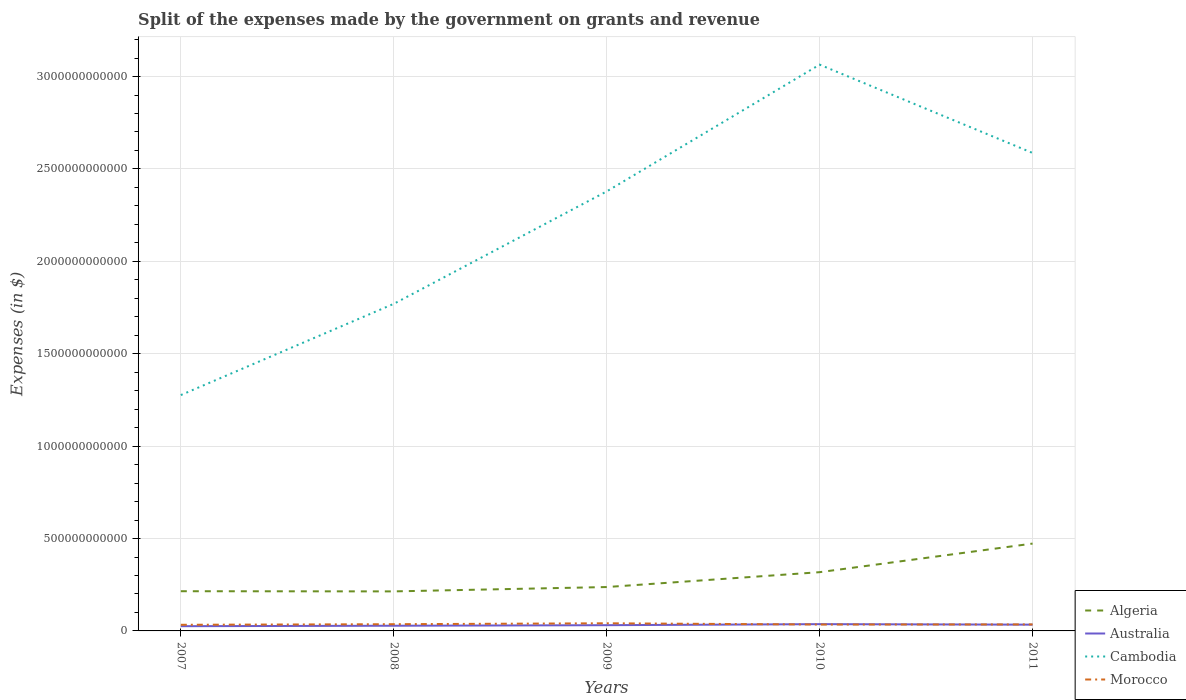How many different coloured lines are there?
Ensure brevity in your answer.  4. Across all years, what is the maximum expenses made by the government on grants and revenue in Morocco?
Your answer should be very brief. 3.32e+1. What is the total expenses made by the government on grants and revenue in Australia in the graph?
Keep it short and to the point. -5.63e+09. What is the difference between the highest and the second highest expenses made by the government on grants and revenue in Australia?
Keep it short and to the point. 1.11e+1. What is the difference between the highest and the lowest expenses made by the government on grants and revenue in Morocco?
Offer a very short reply. 2. Is the expenses made by the government on grants and revenue in Australia strictly greater than the expenses made by the government on grants and revenue in Algeria over the years?
Make the answer very short. Yes. How many lines are there?
Ensure brevity in your answer.  4. How many years are there in the graph?
Give a very brief answer. 5. What is the difference between two consecutive major ticks on the Y-axis?
Your answer should be very brief. 5.00e+11. Are the values on the major ticks of Y-axis written in scientific E-notation?
Your answer should be very brief. No. Does the graph contain grids?
Your answer should be very brief. Yes. Where does the legend appear in the graph?
Your answer should be compact. Bottom right. How many legend labels are there?
Offer a very short reply. 4. How are the legend labels stacked?
Provide a succinct answer. Vertical. What is the title of the graph?
Keep it short and to the point. Split of the expenses made by the government on grants and revenue. Does "Djibouti" appear as one of the legend labels in the graph?
Your answer should be compact. No. What is the label or title of the Y-axis?
Your answer should be compact. Expenses (in $). What is the Expenses (in $) of Algeria in 2007?
Your response must be concise. 2.15e+11. What is the Expenses (in $) of Australia in 2007?
Make the answer very short. 2.56e+1. What is the Expenses (in $) of Cambodia in 2007?
Offer a terse response. 1.28e+12. What is the Expenses (in $) of Morocco in 2007?
Offer a terse response. 3.32e+1. What is the Expenses (in $) in Algeria in 2008?
Offer a very short reply. 2.14e+11. What is the Expenses (in $) in Australia in 2008?
Make the answer very short. 2.81e+1. What is the Expenses (in $) of Cambodia in 2008?
Make the answer very short. 1.77e+12. What is the Expenses (in $) of Morocco in 2008?
Give a very brief answer. 3.64e+1. What is the Expenses (in $) in Algeria in 2009?
Provide a succinct answer. 2.37e+11. What is the Expenses (in $) of Australia in 2009?
Make the answer very short. 3.10e+1. What is the Expenses (in $) in Cambodia in 2009?
Give a very brief answer. 2.38e+12. What is the Expenses (in $) in Morocco in 2009?
Your response must be concise. 4.13e+1. What is the Expenses (in $) of Algeria in 2010?
Provide a short and direct response. 3.18e+11. What is the Expenses (in $) in Australia in 2010?
Make the answer very short. 3.67e+1. What is the Expenses (in $) of Cambodia in 2010?
Offer a very short reply. 3.06e+12. What is the Expenses (in $) of Morocco in 2010?
Your answer should be very brief. 3.46e+1. What is the Expenses (in $) of Algeria in 2011?
Your answer should be very brief. 4.73e+11. What is the Expenses (in $) of Australia in 2011?
Ensure brevity in your answer.  3.39e+1. What is the Expenses (in $) of Cambodia in 2011?
Keep it short and to the point. 2.59e+12. What is the Expenses (in $) in Morocco in 2011?
Provide a short and direct response. 3.52e+1. Across all years, what is the maximum Expenses (in $) of Algeria?
Keep it short and to the point. 4.73e+11. Across all years, what is the maximum Expenses (in $) of Australia?
Ensure brevity in your answer.  3.67e+1. Across all years, what is the maximum Expenses (in $) in Cambodia?
Your response must be concise. 3.06e+12. Across all years, what is the maximum Expenses (in $) of Morocco?
Your response must be concise. 4.13e+1. Across all years, what is the minimum Expenses (in $) in Algeria?
Keep it short and to the point. 2.14e+11. Across all years, what is the minimum Expenses (in $) of Australia?
Your answer should be compact. 2.56e+1. Across all years, what is the minimum Expenses (in $) in Cambodia?
Your answer should be compact. 1.28e+12. Across all years, what is the minimum Expenses (in $) of Morocco?
Offer a terse response. 3.32e+1. What is the total Expenses (in $) in Algeria in the graph?
Provide a short and direct response. 1.46e+12. What is the total Expenses (in $) in Australia in the graph?
Provide a short and direct response. 1.55e+11. What is the total Expenses (in $) in Cambodia in the graph?
Offer a terse response. 1.11e+13. What is the total Expenses (in $) of Morocco in the graph?
Offer a very short reply. 1.81e+11. What is the difference between the Expenses (in $) in Algeria in 2007 and that in 2008?
Offer a very short reply. 9.60e+08. What is the difference between the Expenses (in $) of Australia in 2007 and that in 2008?
Give a very brief answer. -2.50e+09. What is the difference between the Expenses (in $) of Cambodia in 2007 and that in 2008?
Your answer should be compact. -4.94e+11. What is the difference between the Expenses (in $) in Morocco in 2007 and that in 2008?
Provide a succinct answer. -3.19e+09. What is the difference between the Expenses (in $) in Algeria in 2007 and that in 2009?
Your response must be concise. -2.26e+1. What is the difference between the Expenses (in $) of Australia in 2007 and that in 2009?
Offer a terse response. -5.43e+09. What is the difference between the Expenses (in $) in Cambodia in 2007 and that in 2009?
Offer a terse response. -1.10e+12. What is the difference between the Expenses (in $) in Morocco in 2007 and that in 2009?
Offer a terse response. -8.13e+09. What is the difference between the Expenses (in $) in Algeria in 2007 and that in 2010?
Offer a terse response. -1.03e+11. What is the difference between the Expenses (in $) of Australia in 2007 and that in 2010?
Provide a short and direct response. -1.11e+1. What is the difference between the Expenses (in $) of Cambodia in 2007 and that in 2010?
Provide a short and direct response. -1.79e+12. What is the difference between the Expenses (in $) of Morocco in 2007 and that in 2010?
Offer a very short reply. -1.40e+09. What is the difference between the Expenses (in $) of Algeria in 2007 and that in 2011?
Provide a short and direct response. -2.58e+11. What is the difference between the Expenses (in $) in Australia in 2007 and that in 2011?
Provide a short and direct response. -8.32e+09. What is the difference between the Expenses (in $) in Cambodia in 2007 and that in 2011?
Offer a terse response. -1.31e+12. What is the difference between the Expenses (in $) of Morocco in 2007 and that in 2011?
Your answer should be very brief. -2.01e+09. What is the difference between the Expenses (in $) in Algeria in 2008 and that in 2009?
Your response must be concise. -2.36e+1. What is the difference between the Expenses (in $) of Australia in 2008 and that in 2009?
Your answer should be compact. -2.93e+09. What is the difference between the Expenses (in $) in Cambodia in 2008 and that in 2009?
Keep it short and to the point. -6.08e+11. What is the difference between the Expenses (in $) in Morocco in 2008 and that in 2009?
Keep it short and to the point. -4.95e+09. What is the difference between the Expenses (in $) in Algeria in 2008 and that in 2010?
Make the answer very short. -1.04e+11. What is the difference between the Expenses (in $) in Australia in 2008 and that in 2010?
Your answer should be compact. -8.56e+09. What is the difference between the Expenses (in $) of Cambodia in 2008 and that in 2010?
Provide a short and direct response. -1.29e+12. What is the difference between the Expenses (in $) in Morocco in 2008 and that in 2010?
Provide a short and direct response. 1.79e+09. What is the difference between the Expenses (in $) in Algeria in 2008 and that in 2011?
Offer a very short reply. -2.59e+11. What is the difference between the Expenses (in $) in Australia in 2008 and that in 2011?
Your answer should be very brief. -5.81e+09. What is the difference between the Expenses (in $) in Cambodia in 2008 and that in 2011?
Your answer should be compact. -8.17e+11. What is the difference between the Expenses (in $) in Morocco in 2008 and that in 2011?
Make the answer very short. 1.17e+09. What is the difference between the Expenses (in $) in Algeria in 2009 and that in 2010?
Give a very brief answer. -8.04e+1. What is the difference between the Expenses (in $) of Australia in 2009 and that in 2010?
Make the answer very short. -5.63e+09. What is the difference between the Expenses (in $) in Cambodia in 2009 and that in 2010?
Make the answer very short. -6.86e+11. What is the difference between the Expenses (in $) in Morocco in 2009 and that in 2010?
Keep it short and to the point. 6.74e+09. What is the difference between the Expenses (in $) of Algeria in 2009 and that in 2011?
Keep it short and to the point. -2.35e+11. What is the difference between the Expenses (in $) of Australia in 2009 and that in 2011?
Your response must be concise. -2.88e+09. What is the difference between the Expenses (in $) in Cambodia in 2009 and that in 2011?
Ensure brevity in your answer.  -2.08e+11. What is the difference between the Expenses (in $) of Morocco in 2009 and that in 2011?
Ensure brevity in your answer.  6.12e+09. What is the difference between the Expenses (in $) in Algeria in 2010 and that in 2011?
Ensure brevity in your answer.  -1.55e+11. What is the difference between the Expenses (in $) of Australia in 2010 and that in 2011?
Your answer should be compact. 2.75e+09. What is the difference between the Expenses (in $) of Cambodia in 2010 and that in 2011?
Your answer should be very brief. 4.78e+11. What is the difference between the Expenses (in $) of Morocco in 2010 and that in 2011?
Ensure brevity in your answer.  -6.13e+08. What is the difference between the Expenses (in $) in Algeria in 2007 and the Expenses (in $) in Australia in 2008?
Offer a very short reply. 1.87e+11. What is the difference between the Expenses (in $) of Algeria in 2007 and the Expenses (in $) of Cambodia in 2008?
Provide a succinct answer. -1.56e+12. What is the difference between the Expenses (in $) in Algeria in 2007 and the Expenses (in $) in Morocco in 2008?
Offer a very short reply. 1.78e+11. What is the difference between the Expenses (in $) in Australia in 2007 and the Expenses (in $) in Cambodia in 2008?
Keep it short and to the point. -1.74e+12. What is the difference between the Expenses (in $) in Australia in 2007 and the Expenses (in $) in Morocco in 2008?
Offer a very short reply. -1.08e+1. What is the difference between the Expenses (in $) of Cambodia in 2007 and the Expenses (in $) of Morocco in 2008?
Your answer should be very brief. 1.24e+12. What is the difference between the Expenses (in $) of Algeria in 2007 and the Expenses (in $) of Australia in 2009?
Keep it short and to the point. 1.84e+11. What is the difference between the Expenses (in $) in Algeria in 2007 and the Expenses (in $) in Cambodia in 2009?
Make the answer very short. -2.16e+12. What is the difference between the Expenses (in $) of Algeria in 2007 and the Expenses (in $) of Morocco in 2009?
Provide a succinct answer. 1.74e+11. What is the difference between the Expenses (in $) of Australia in 2007 and the Expenses (in $) of Cambodia in 2009?
Keep it short and to the point. -2.35e+12. What is the difference between the Expenses (in $) in Australia in 2007 and the Expenses (in $) in Morocco in 2009?
Provide a succinct answer. -1.57e+1. What is the difference between the Expenses (in $) in Cambodia in 2007 and the Expenses (in $) in Morocco in 2009?
Make the answer very short. 1.23e+12. What is the difference between the Expenses (in $) in Algeria in 2007 and the Expenses (in $) in Australia in 2010?
Your answer should be compact. 1.78e+11. What is the difference between the Expenses (in $) in Algeria in 2007 and the Expenses (in $) in Cambodia in 2010?
Keep it short and to the point. -2.85e+12. What is the difference between the Expenses (in $) of Algeria in 2007 and the Expenses (in $) of Morocco in 2010?
Provide a succinct answer. 1.80e+11. What is the difference between the Expenses (in $) in Australia in 2007 and the Expenses (in $) in Cambodia in 2010?
Provide a short and direct response. -3.04e+12. What is the difference between the Expenses (in $) in Australia in 2007 and the Expenses (in $) in Morocco in 2010?
Your response must be concise. -8.99e+09. What is the difference between the Expenses (in $) of Cambodia in 2007 and the Expenses (in $) of Morocco in 2010?
Give a very brief answer. 1.24e+12. What is the difference between the Expenses (in $) of Algeria in 2007 and the Expenses (in $) of Australia in 2011?
Offer a very short reply. 1.81e+11. What is the difference between the Expenses (in $) in Algeria in 2007 and the Expenses (in $) in Cambodia in 2011?
Offer a terse response. -2.37e+12. What is the difference between the Expenses (in $) in Algeria in 2007 and the Expenses (in $) in Morocco in 2011?
Offer a very short reply. 1.80e+11. What is the difference between the Expenses (in $) in Australia in 2007 and the Expenses (in $) in Cambodia in 2011?
Offer a terse response. -2.56e+12. What is the difference between the Expenses (in $) of Australia in 2007 and the Expenses (in $) of Morocco in 2011?
Offer a terse response. -9.60e+09. What is the difference between the Expenses (in $) in Cambodia in 2007 and the Expenses (in $) in Morocco in 2011?
Your response must be concise. 1.24e+12. What is the difference between the Expenses (in $) of Algeria in 2008 and the Expenses (in $) of Australia in 2009?
Offer a very short reply. 1.83e+11. What is the difference between the Expenses (in $) of Algeria in 2008 and the Expenses (in $) of Cambodia in 2009?
Your response must be concise. -2.16e+12. What is the difference between the Expenses (in $) in Algeria in 2008 and the Expenses (in $) in Morocco in 2009?
Provide a short and direct response. 1.73e+11. What is the difference between the Expenses (in $) in Australia in 2008 and the Expenses (in $) in Cambodia in 2009?
Give a very brief answer. -2.35e+12. What is the difference between the Expenses (in $) in Australia in 2008 and the Expenses (in $) in Morocco in 2009?
Make the answer very short. -1.32e+1. What is the difference between the Expenses (in $) of Cambodia in 2008 and the Expenses (in $) of Morocco in 2009?
Provide a short and direct response. 1.73e+12. What is the difference between the Expenses (in $) in Algeria in 2008 and the Expenses (in $) in Australia in 2010?
Provide a succinct answer. 1.77e+11. What is the difference between the Expenses (in $) in Algeria in 2008 and the Expenses (in $) in Cambodia in 2010?
Your answer should be very brief. -2.85e+12. What is the difference between the Expenses (in $) in Algeria in 2008 and the Expenses (in $) in Morocco in 2010?
Give a very brief answer. 1.79e+11. What is the difference between the Expenses (in $) of Australia in 2008 and the Expenses (in $) of Cambodia in 2010?
Keep it short and to the point. -3.04e+12. What is the difference between the Expenses (in $) of Australia in 2008 and the Expenses (in $) of Morocco in 2010?
Your response must be concise. -6.49e+09. What is the difference between the Expenses (in $) in Cambodia in 2008 and the Expenses (in $) in Morocco in 2010?
Your answer should be very brief. 1.74e+12. What is the difference between the Expenses (in $) in Algeria in 2008 and the Expenses (in $) in Australia in 2011?
Provide a short and direct response. 1.80e+11. What is the difference between the Expenses (in $) in Algeria in 2008 and the Expenses (in $) in Cambodia in 2011?
Provide a succinct answer. -2.37e+12. What is the difference between the Expenses (in $) in Algeria in 2008 and the Expenses (in $) in Morocco in 2011?
Keep it short and to the point. 1.79e+11. What is the difference between the Expenses (in $) in Australia in 2008 and the Expenses (in $) in Cambodia in 2011?
Make the answer very short. -2.56e+12. What is the difference between the Expenses (in $) in Australia in 2008 and the Expenses (in $) in Morocco in 2011?
Ensure brevity in your answer.  -7.10e+09. What is the difference between the Expenses (in $) of Cambodia in 2008 and the Expenses (in $) of Morocco in 2011?
Your response must be concise. 1.73e+12. What is the difference between the Expenses (in $) in Algeria in 2009 and the Expenses (in $) in Australia in 2010?
Make the answer very short. 2.01e+11. What is the difference between the Expenses (in $) of Algeria in 2009 and the Expenses (in $) of Cambodia in 2010?
Give a very brief answer. -2.83e+12. What is the difference between the Expenses (in $) of Algeria in 2009 and the Expenses (in $) of Morocco in 2010?
Your answer should be compact. 2.03e+11. What is the difference between the Expenses (in $) in Australia in 2009 and the Expenses (in $) in Cambodia in 2010?
Offer a terse response. -3.03e+12. What is the difference between the Expenses (in $) in Australia in 2009 and the Expenses (in $) in Morocco in 2010?
Give a very brief answer. -3.56e+09. What is the difference between the Expenses (in $) in Cambodia in 2009 and the Expenses (in $) in Morocco in 2010?
Keep it short and to the point. 2.34e+12. What is the difference between the Expenses (in $) of Algeria in 2009 and the Expenses (in $) of Australia in 2011?
Your answer should be compact. 2.04e+11. What is the difference between the Expenses (in $) in Algeria in 2009 and the Expenses (in $) in Cambodia in 2011?
Keep it short and to the point. -2.35e+12. What is the difference between the Expenses (in $) in Algeria in 2009 and the Expenses (in $) in Morocco in 2011?
Your response must be concise. 2.02e+11. What is the difference between the Expenses (in $) in Australia in 2009 and the Expenses (in $) in Cambodia in 2011?
Your answer should be compact. -2.56e+12. What is the difference between the Expenses (in $) in Australia in 2009 and the Expenses (in $) in Morocco in 2011?
Ensure brevity in your answer.  -4.17e+09. What is the difference between the Expenses (in $) in Cambodia in 2009 and the Expenses (in $) in Morocco in 2011?
Keep it short and to the point. 2.34e+12. What is the difference between the Expenses (in $) in Algeria in 2010 and the Expenses (in $) in Australia in 2011?
Keep it short and to the point. 2.84e+11. What is the difference between the Expenses (in $) in Algeria in 2010 and the Expenses (in $) in Cambodia in 2011?
Your answer should be compact. -2.27e+12. What is the difference between the Expenses (in $) of Algeria in 2010 and the Expenses (in $) of Morocco in 2011?
Keep it short and to the point. 2.83e+11. What is the difference between the Expenses (in $) of Australia in 2010 and the Expenses (in $) of Cambodia in 2011?
Provide a succinct answer. -2.55e+12. What is the difference between the Expenses (in $) of Australia in 2010 and the Expenses (in $) of Morocco in 2011?
Ensure brevity in your answer.  1.46e+09. What is the difference between the Expenses (in $) of Cambodia in 2010 and the Expenses (in $) of Morocco in 2011?
Your response must be concise. 3.03e+12. What is the average Expenses (in $) of Algeria per year?
Offer a very short reply. 2.91e+11. What is the average Expenses (in $) of Australia per year?
Give a very brief answer. 3.11e+1. What is the average Expenses (in $) of Cambodia per year?
Give a very brief answer. 2.22e+12. What is the average Expenses (in $) in Morocco per year?
Provide a short and direct response. 3.61e+1. In the year 2007, what is the difference between the Expenses (in $) of Algeria and Expenses (in $) of Australia?
Keep it short and to the point. 1.89e+11. In the year 2007, what is the difference between the Expenses (in $) of Algeria and Expenses (in $) of Cambodia?
Keep it short and to the point. -1.06e+12. In the year 2007, what is the difference between the Expenses (in $) in Algeria and Expenses (in $) in Morocco?
Make the answer very short. 1.82e+11. In the year 2007, what is the difference between the Expenses (in $) in Australia and Expenses (in $) in Cambodia?
Offer a terse response. -1.25e+12. In the year 2007, what is the difference between the Expenses (in $) in Australia and Expenses (in $) in Morocco?
Provide a succinct answer. -7.59e+09. In the year 2007, what is the difference between the Expenses (in $) of Cambodia and Expenses (in $) of Morocco?
Offer a very short reply. 1.24e+12. In the year 2008, what is the difference between the Expenses (in $) in Algeria and Expenses (in $) in Australia?
Your response must be concise. 1.86e+11. In the year 2008, what is the difference between the Expenses (in $) in Algeria and Expenses (in $) in Cambodia?
Give a very brief answer. -1.56e+12. In the year 2008, what is the difference between the Expenses (in $) of Algeria and Expenses (in $) of Morocco?
Make the answer very short. 1.78e+11. In the year 2008, what is the difference between the Expenses (in $) of Australia and Expenses (in $) of Cambodia?
Your answer should be compact. -1.74e+12. In the year 2008, what is the difference between the Expenses (in $) of Australia and Expenses (in $) of Morocco?
Give a very brief answer. -8.27e+09. In the year 2008, what is the difference between the Expenses (in $) of Cambodia and Expenses (in $) of Morocco?
Ensure brevity in your answer.  1.73e+12. In the year 2009, what is the difference between the Expenses (in $) in Algeria and Expenses (in $) in Australia?
Make the answer very short. 2.06e+11. In the year 2009, what is the difference between the Expenses (in $) of Algeria and Expenses (in $) of Cambodia?
Keep it short and to the point. -2.14e+12. In the year 2009, what is the difference between the Expenses (in $) in Algeria and Expenses (in $) in Morocco?
Give a very brief answer. 1.96e+11. In the year 2009, what is the difference between the Expenses (in $) in Australia and Expenses (in $) in Cambodia?
Provide a short and direct response. -2.35e+12. In the year 2009, what is the difference between the Expenses (in $) of Australia and Expenses (in $) of Morocco?
Give a very brief answer. -1.03e+1. In the year 2009, what is the difference between the Expenses (in $) in Cambodia and Expenses (in $) in Morocco?
Your answer should be compact. 2.34e+12. In the year 2010, what is the difference between the Expenses (in $) of Algeria and Expenses (in $) of Australia?
Your response must be concise. 2.81e+11. In the year 2010, what is the difference between the Expenses (in $) in Algeria and Expenses (in $) in Cambodia?
Your response must be concise. -2.75e+12. In the year 2010, what is the difference between the Expenses (in $) of Algeria and Expenses (in $) of Morocco?
Ensure brevity in your answer.  2.83e+11. In the year 2010, what is the difference between the Expenses (in $) in Australia and Expenses (in $) in Cambodia?
Make the answer very short. -3.03e+12. In the year 2010, what is the difference between the Expenses (in $) of Australia and Expenses (in $) of Morocco?
Your answer should be very brief. 2.07e+09. In the year 2010, what is the difference between the Expenses (in $) in Cambodia and Expenses (in $) in Morocco?
Give a very brief answer. 3.03e+12. In the year 2011, what is the difference between the Expenses (in $) in Algeria and Expenses (in $) in Australia?
Offer a very short reply. 4.39e+11. In the year 2011, what is the difference between the Expenses (in $) of Algeria and Expenses (in $) of Cambodia?
Provide a short and direct response. -2.11e+12. In the year 2011, what is the difference between the Expenses (in $) in Algeria and Expenses (in $) in Morocco?
Provide a succinct answer. 4.37e+11. In the year 2011, what is the difference between the Expenses (in $) in Australia and Expenses (in $) in Cambodia?
Your answer should be compact. -2.55e+12. In the year 2011, what is the difference between the Expenses (in $) of Australia and Expenses (in $) of Morocco?
Keep it short and to the point. -1.29e+09. In the year 2011, what is the difference between the Expenses (in $) of Cambodia and Expenses (in $) of Morocco?
Make the answer very short. 2.55e+12. What is the ratio of the Expenses (in $) of Australia in 2007 to that in 2008?
Ensure brevity in your answer.  0.91. What is the ratio of the Expenses (in $) in Cambodia in 2007 to that in 2008?
Ensure brevity in your answer.  0.72. What is the ratio of the Expenses (in $) in Morocco in 2007 to that in 2008?
Ensure brevity in your answer.  0.91. What is the ratio of the Expenses (in $) of Algeria in 2007 to that in 2009?
Offer a terse response. 0.9. What is the ratio of the Expenses (in $) of Australia in 2007 to that in 2009?
Your answer should be very brief. 0.82. What is the ratio of the Expenses (in $) of Cambodia in 2007 to that in 2009?
Your answer should be very brief. 0.54. What is the ratio of the Expenses (in $) of Morocco in 2007 to that in 2009?
Your response must be concise. 0.8. What is the ratio of the Expenses (in $) of Algeria in 2007 to that in 2010?
Your answer should be compact. 0.68. What is the ratio of the Expenses (in $) of Australia in 2007 to that in 2010?
Keep it short and to the point. 0.7. What is the ratio of the Expenses (in $) of Cambodia in 2007 to that in 2010?
Your answer should be compact. 0.42. What is the ratio of the Expenses (in $) of Morocco in 2007 to that in 2010?
Your response must be concise. 0.96. What is the ratio of the Expenses (in $) in Algeria in 2007 to that in 2011?
Keep it short and to the point. 0.45. What is the ratio of the Expenses (in $) of Australia in 2007 to that in 2011?
Your answer should be very brief. 0.75. What is the ratio of the Expenses (in $) in Cambodia in 2007 to that in 2011?
Make the answer very short. 0.49. What is the ratio of the Expenses (in $) in Morocco in 2007 to that in 2011?
Provide a short and direct response. 0.94. What is the ratio of the Expenses (in $) of Algeria in 2008 to that in 2009?
Provide a short and direct response. 0.9. What is the ratio of the Expenses (in $) in Australia in 2008 to that in 2009?
Make the answer very short. 0.91. What is the ratio of the Expenses (in $) of Cambodia in 2008 to that in 2009?
Ensure brevity in your answer.  0.74. What is the ratio of the Expenses (in $) in Morocco in 2008 to that in 2009?
Offer a very short reply. 0.88. What is the ratio of the Expenses (in $) in Algeria in 2008 to that in 2010?
Offer a very short reply. 0.67. What is the ratio of the Expenses (in $) in Australia in 2008 to that in 2010?
Offer a very short reply. 0.77. What is the ratio of the Expenses (in $) in Cambodia in 2008 to that in 2010?
Your response must be concise. 0.58. What is the ratio of the Expenses (in $) of Morocco in 2008 to that in 2010?
Provide a succinct answer. 1.05. What is the ratio of the Expenses (in $) of Algeria in 2008 to that in 2011?
Offer a very short reply. 0.45. What is the ratio of the Expenses (in $) in Australia in 2008 to that in 2011?
Your answer should be compact. 0.83. What is the ratio of the Expenses (in $) in Cambodia in 2008 to that in 2011?
Offer a terse response. 0.68. What is the ratio of the Expenses (in $) of Morocco in 2008 to that in 2011?
Your answer should be very brief. 1.03. What is the ratio of the Expenses (in $) of Algeria in 2009 to that in 2010?
Your answer should be very brief. 0.75. What is the ratio of the Expenses (in $) of Australia in 2009 to that in 2010?
Your response must be concise. 0.85. What is the ratio of the Expenses (in $) of Cambodia in 2009 to that in 2010?
Offer a very short reply. 0.78. What is the ratio of the Expenses (in $) of Morocco in 2009 to that in 2010?
Ensure brevity in your answer.  1.19. What is the ratio of the Expenses (in $) in Algeria in 2009 to that in 2011?
Your response must be concise. 0.5. What is the ratio of the Expenses (in $) in Australia in 2009 to that in 2011?
Your answer should be very brief. 0.92. What is the ratio of the Expenses (in $) of Cambodia in 2009 to that in 2011?
Your answer should be very brief. 0.92. What is the ratio of the Expenses (in $) of Morocco in 2009 to that in 2011?
Your response must be concise. 1.17. What is the ratio of the Expenses (in $) in Algeria in 2010 to that in 2011?
Your answer should be compact. 0.67. What is the ratio of the Expenses (in $) in Australia in 2010 to that in 2011?
Provide a short and direct response. 1.08. What is the ratio of the Expenses (in $) of Cambodia in 2010 to that in 2011?
Provide a succinct answer. 1.18. What is the ratio of the Expenses (in $) of Morocco in 2010 to that in 2011?
Ensure brevity in your answer.  0.98. What is the difference between the highest and the second highest Expenses (in $) of Algeria?
Ensure brevity in your answer.  1.55e+11. What is the difference between the highest and the second highest Expenses (in $) of Australia?
Offer a very short reply. 2.75e+09. What is the difference between the highest and the second highest Expenses (in $) in Cambodia?
Give a very brief answer. 4.78e+11. What is the difference between the highest and the second highest Expenses (in $) in Morocco?
Make the answer very short. 4.95e+09. What is the difference between the highest and the lowest Expenses (in $) of Algeria?
Your response must be concise. 2.59e+11. What is the difference between the highest and the lowest Expenses (in $) in Australia?
Keep it short and to the point. 1.11e+1. What is the difference between the highest and the lowest Expenses (in $) in Cambodia?
Your answer should be compact. 1.79e+12. What is the difference between the highest and the lowest Expenses (in $) in Morocco?
Your response must be concise. 8.13e+09. 